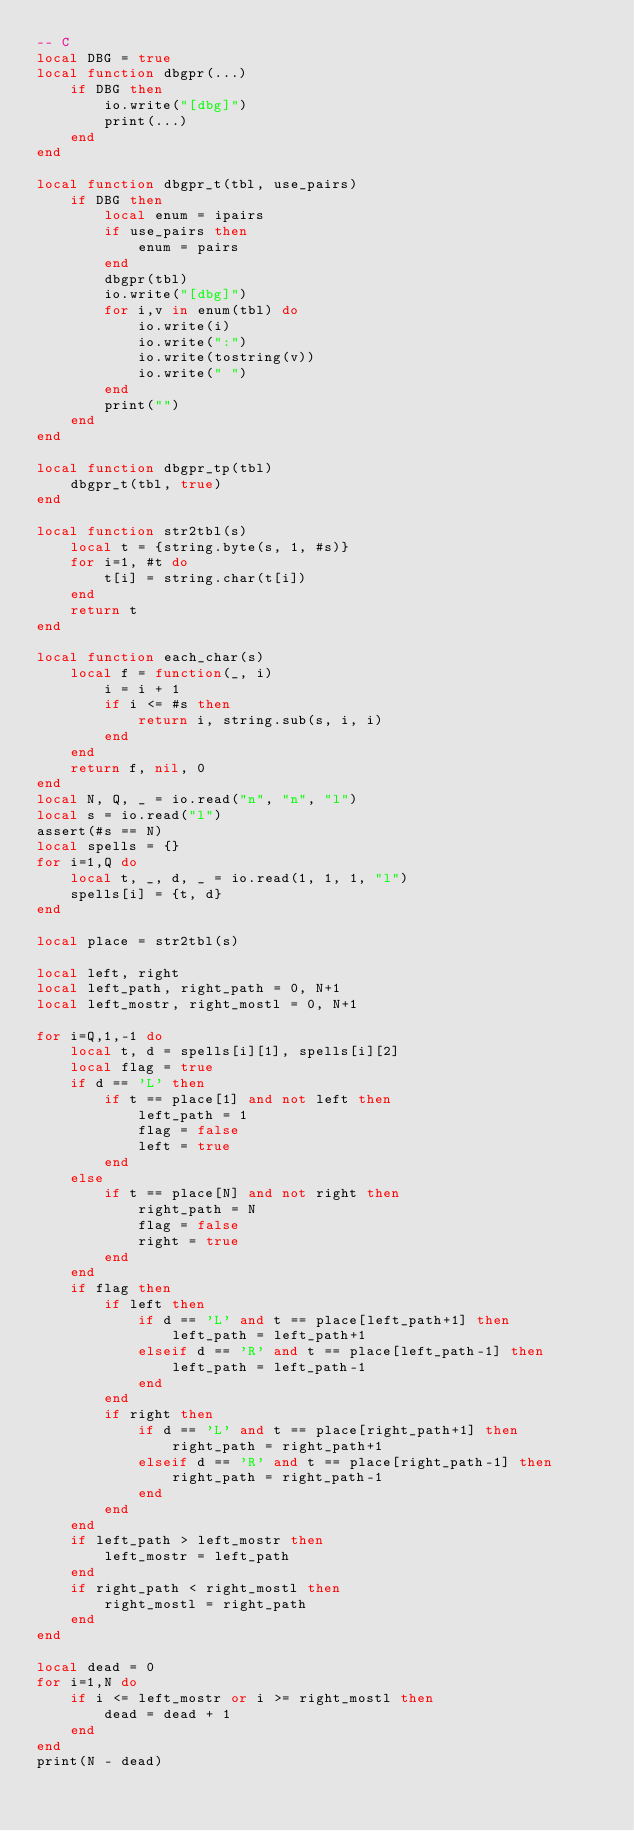Convert code to text. <code><loc_0><loc_0><loc_500><loc_500><_Lua_>-- C
local DBG = true
local function dbgpr(...)
    if DBG then
        io.write("[dbg]")
        print(...)
    end
end

local function dbgpr_t(tbl, use_pairs)
    if DBG then
        local enum = ipairs
        if use_pairs then
            enum = pairs
        end
        dbgpr(tbl)
        io.write("[dbg]")
        for i,v in enum(tbl) do
            io.write(i)
            io.write(":")
            io.write(tostring(v))
            io.write(" ")
        end
        print("")
    end
end

local function dbgpr_tp(tbl)
    dbgpr_t(tbl, true)
end

local function str2tbl(s)
    local t = {string.byte(s, 1, #s)}
    for i=1, #t do
        t[i] = string.char(t[i])
    end
    return t
end

local function each_char(s)
    local f = function(_, i)
        i = i + 1
        if i <= #s then
            return i, string.sub(s, i, i)
        end
    end
    return f, nil, 0
end
local N, Q, _ = io.read("n", "n", "l")
local s = io.read("l")
assert(#s == N)
local spells = {}
for i=1,Q do
    local t, _, d, _ = io.read(1, 1, 1, "l")
    spells[i] = {t, d}
end

local place = str2tbl(s)

local left, right
local left_path, right_path = 0, N+1
local left_mostr, right_mostl = 0, N+1

for i=Q,1,-1 do
    local t, d = spells[i][1], spells[i][2]
    local flag = true
    if d == 'L' then
        if t == place[1] and not left then
            left_path = 1
            flag = false
            left = true
        end
    else
        if t == place[N] and not right then
            right_path = N
            flag = false
            right = true
        end
    end
    if flag then
        if left then
            if d == 'L' and t == place[left_path+1] then
                left_path = left_path+1
            elseif d == 'R' and t == place[left_path-1] then
                left_path = left_path-1
            end
        end
        if right then
            if d == 'L' and t == place[right_path+1] then
                right_path = right_path+1
            elseif d == 'R' and t == place[right_path-1] then
                right_path = right_path-1
            end
        end
    end
    if left_path > left_mostr then
        left_mostr = left_path
    end
    if right_path < right_mostl then
        right_mostl = right_path
    end
end

local dead = 0
for i=1,N do
    if i <= left_mostr or i >= right_mostl then
        dead = dead + 1
    end
end
print(N - dead)</code> 